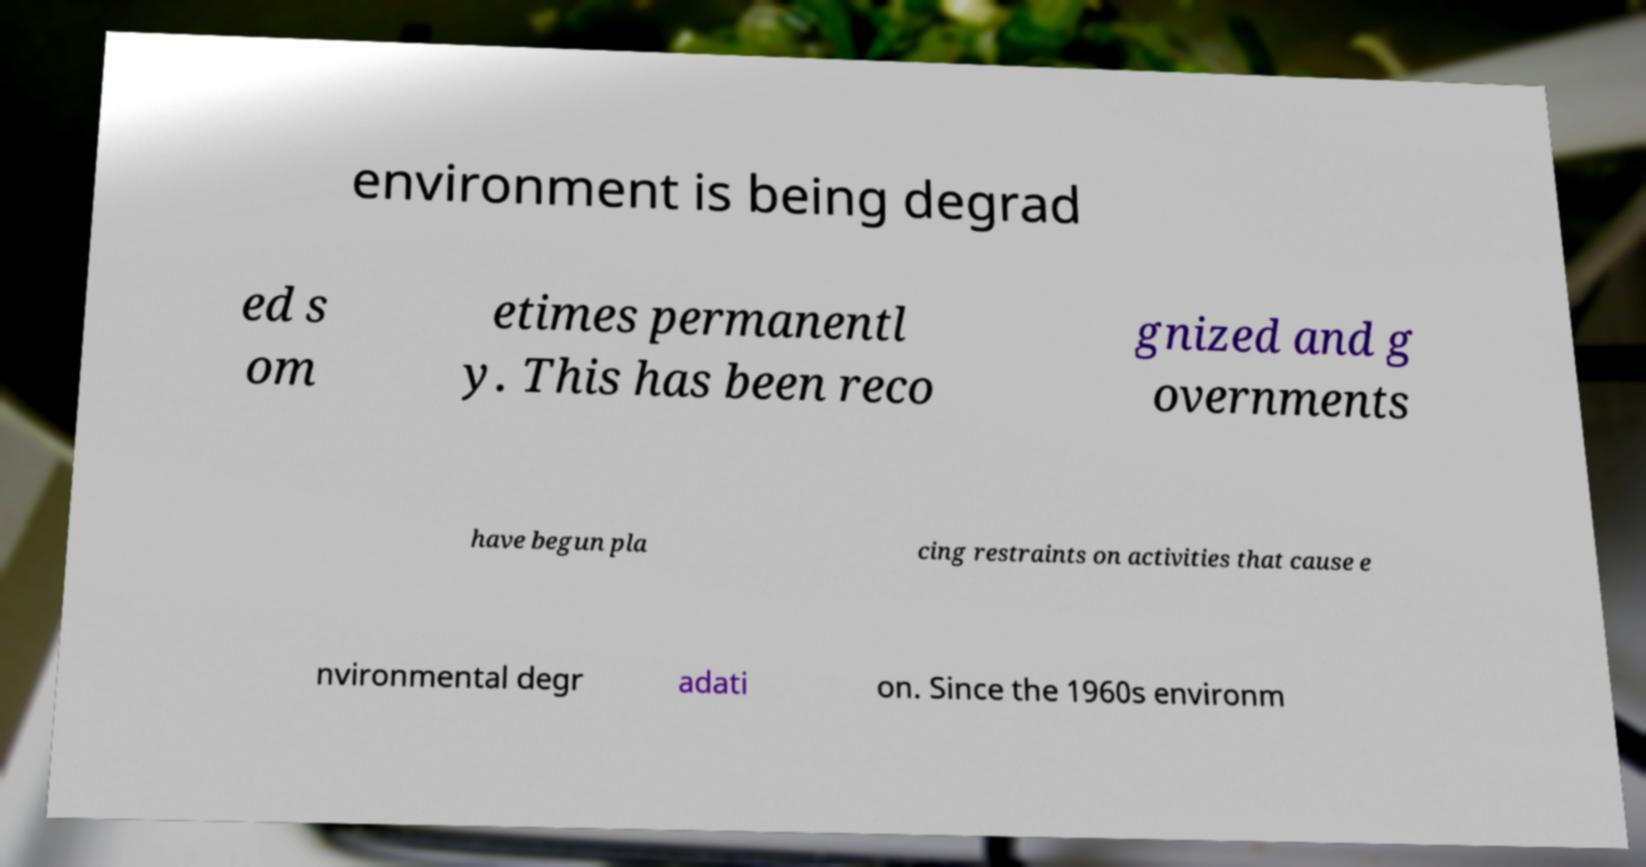Can you read and provide the text displayed in the image?This photo seems to have some interesting text. Can you extract and type it out for me? environment is being degrad ed s om etimes permanentl y. This has been reco gnized and g overnments have begun pla cing restraints on activities that cause e nvironmental degr adati on. Since the 1960s environm 